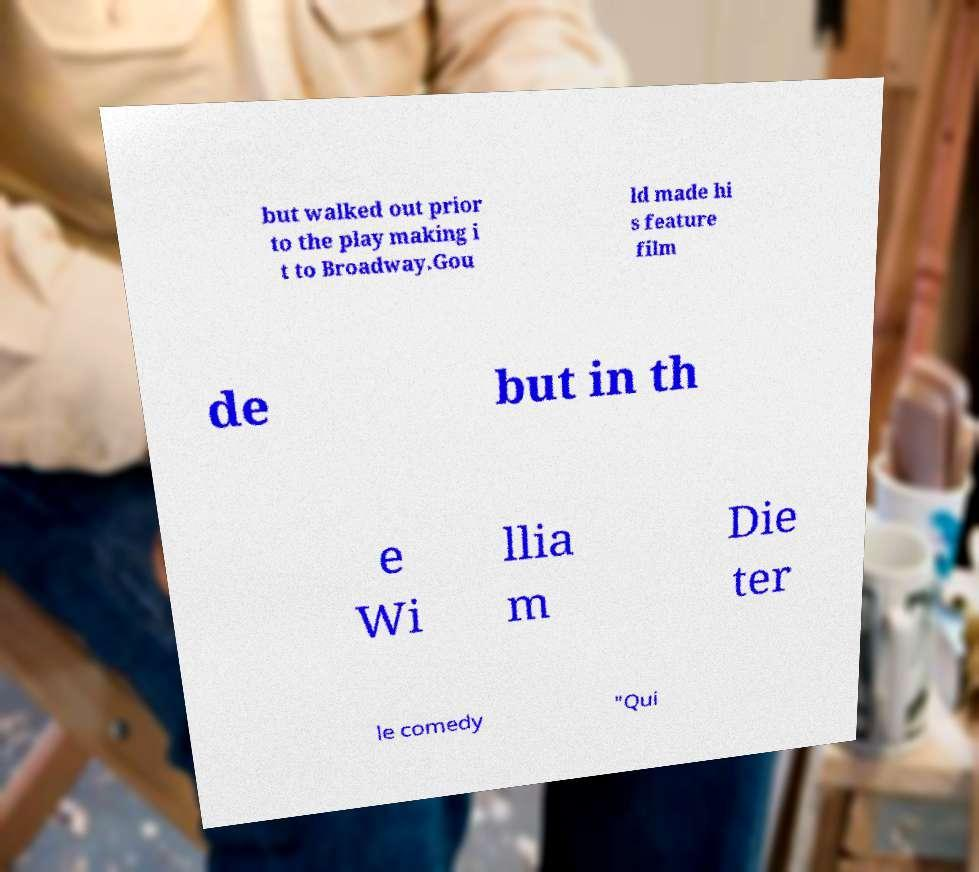Can you read and provide the text displayed in the image?This photo seems to have some interesting text. Can you extract and type it out for me? but walked out prior to the play making i t to Broadway.Gou ld made hi s feature film de but in th e Wi llia m Die ter le comedy "Qui 